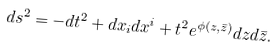<formula> <loc_0><loc_0><loc_500><loc_500>d s ^ { 2 } = - d t ^ { 2 } + d x _ { i } d x ^ { i } + t ^ { 2 } e ^ { \phi ( z , \bar { z } ) } d z d \bar { z } .</formula> 